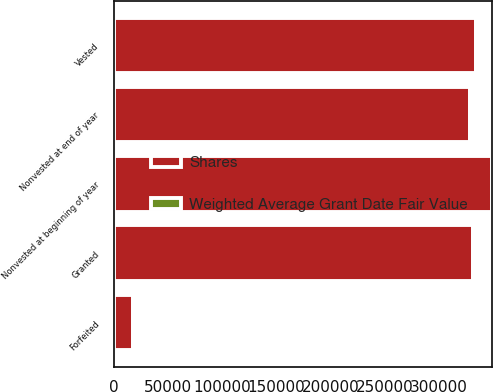Convert chart. <chart><loc_0><loc_0><loc_500><loc_500><stacked_bar_chart><ecel><fcel>Nonvested at beginning of year<fcel>Granted<fcel>Vested<fcel>Forfeited<fcel>Nonvested at end of year<nl><fcel>Shares<fcel>348642<fcel>331533<fcel>333893<fcel>17156<fcel>329126<nl><fcel>Weighted Average Grant Date Fair Value<fcel>2.47<fcel>3.13<fcel>2.65<fcel>1.3<fcel>2.92<nl></chart> 